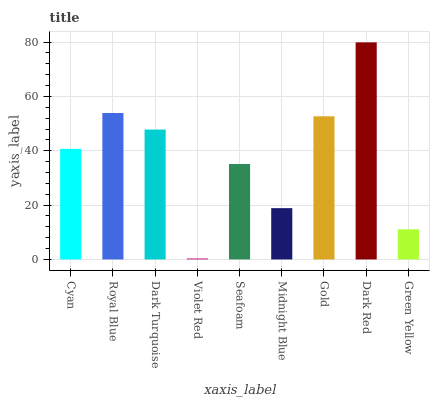Is Violet Red the minimum?
Answer yes or no. Yes. Is Dark Red the maximum?
Answer yes or no. Yes. Is Royal Blue the minimum?
Answer yes or no. No. Is Royal Blue the maximum?
Answer yes or no. No. Is Royal Blue greater than Cyan?
Answer yes or no. Yes. Is Cyan less than Royal Blue?
Answer yes or no. Yes. Is Cyan greater than Royal Blue?
Answer yes or no. No. Is Royal Blue less than Cyan?
Answer yes or no. No. Is Cyan the high median?
Answer yes or no. Yes. Is Cyan the low median?
Answer yes or no. Yes. Is Seafoam the high median?
Answer yes or no. No. Is Violet Red the low median?
Answer yes or no. No. 